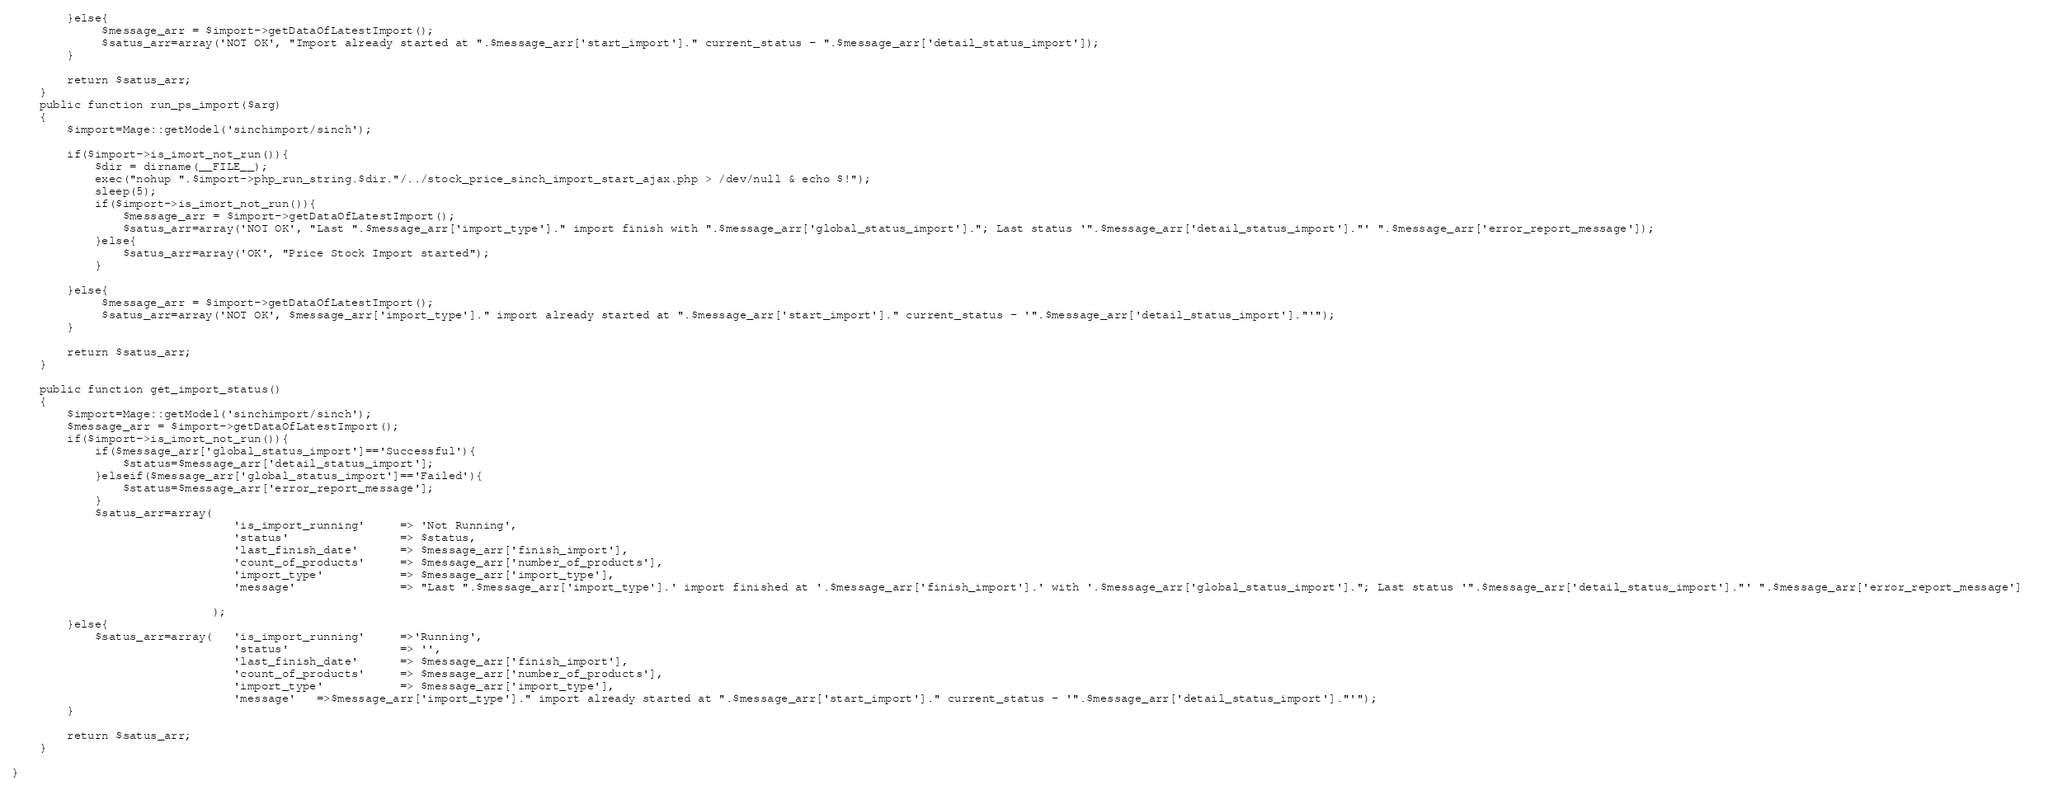Convert code to text. <code><loc_0><loc_0><loc_500><loc_500><_PHP_>
        }else{
             $message_arr = $import->getDataOfLatestImport();             
             $satus_arr=array('NOT OK', "Import already started at ".$message_arr['start_import']." current_status - ".$message_arr['detail_status_import']);
        }

        return $satus_arr;
    }
    public function run_ps_import($arg)
    {
        $import=Mage::getModel('sinchimport/sinch');

        if($import->is_imort_not_run()){            
            $dir = dirname(__FILE__);
            exec("nohup ".$import->php_run_string.$dir."/../stock_price_sinch_import_start_ajax.php > /dev/null & echo $!");    
            sleep(5);
            if($import->is_imort_not_run()){
                $message_arr = $import->getDataOfLatestImport();
                $satus_arr=array('NOT OK', "Last ".$message_arr['import_type']." import finish with ".$message_arr['global_status_import']."; Last status '".$message_arr['detail_status_import']."' ".$message_arr['error_report_message']);
            }else{    
                $satus_arr=array('OK', "Price Stock Import started");
            }

        }else{
             $message_arr = $import->getDataOfLatestImport();             
             $satus_arr=array('NOT OK', $message_arr['import_type']." import already started at ".$message_arr['start_import']." current_status - '".$message_arr['detail_status_import']."'");
        }

        return $satus_arr;
    }

    public function get_import_status()
    {
        $import=Mage::getModel('sinchimport/sinch');
        $message_arr = $import->getDataOfLatestImport();
        if($import->is_imort_not_run()){
            if($message_arr['global_status_import']=='Successful'){
                $status=$message_arr['detail_status_import'];
            }elseif($message_arr['global_status_import']=='Failed'){
                $status=$message_arr['error_report_message'];
            }
            $satus_arr=array(
                                'is_import_running'     => 'Not Running',
                                'status'                => $status,
                                'last_finish_date'      => $message_arr['finish_import'],
                                'count_of_products'     => $message_arr['number_of_products'],
                                'import_type'           => $message_arr['import_type'],
                                'message'               => "Last ".$message_arr['import_type'].' import finished at '.$message_arr['finish_import'].' with '.$message_arr['global_status_import']."; Last status '".$message_arr['detail_status_import']."' ".$message_arr['error_report_message']  
                                    
                             );
        }else{
            $satus_arr=array(   'is_import_running'     =>'Running', 
                                'status'                => '',
                                'last_finish_date'      => $message_arr['finish_import'],
                                'count_of_products'     => $message_arr['number_of_products'],
                                'import_type'           => $message_arr['import_type'],
                                'message'   =>$message_arr['import_type']." import already started at ".$message_arr['start_import']." current_status - '".$message_arr['detail_status_import']."'");
        }

        return $satus_arr;
    }

}
</code> 